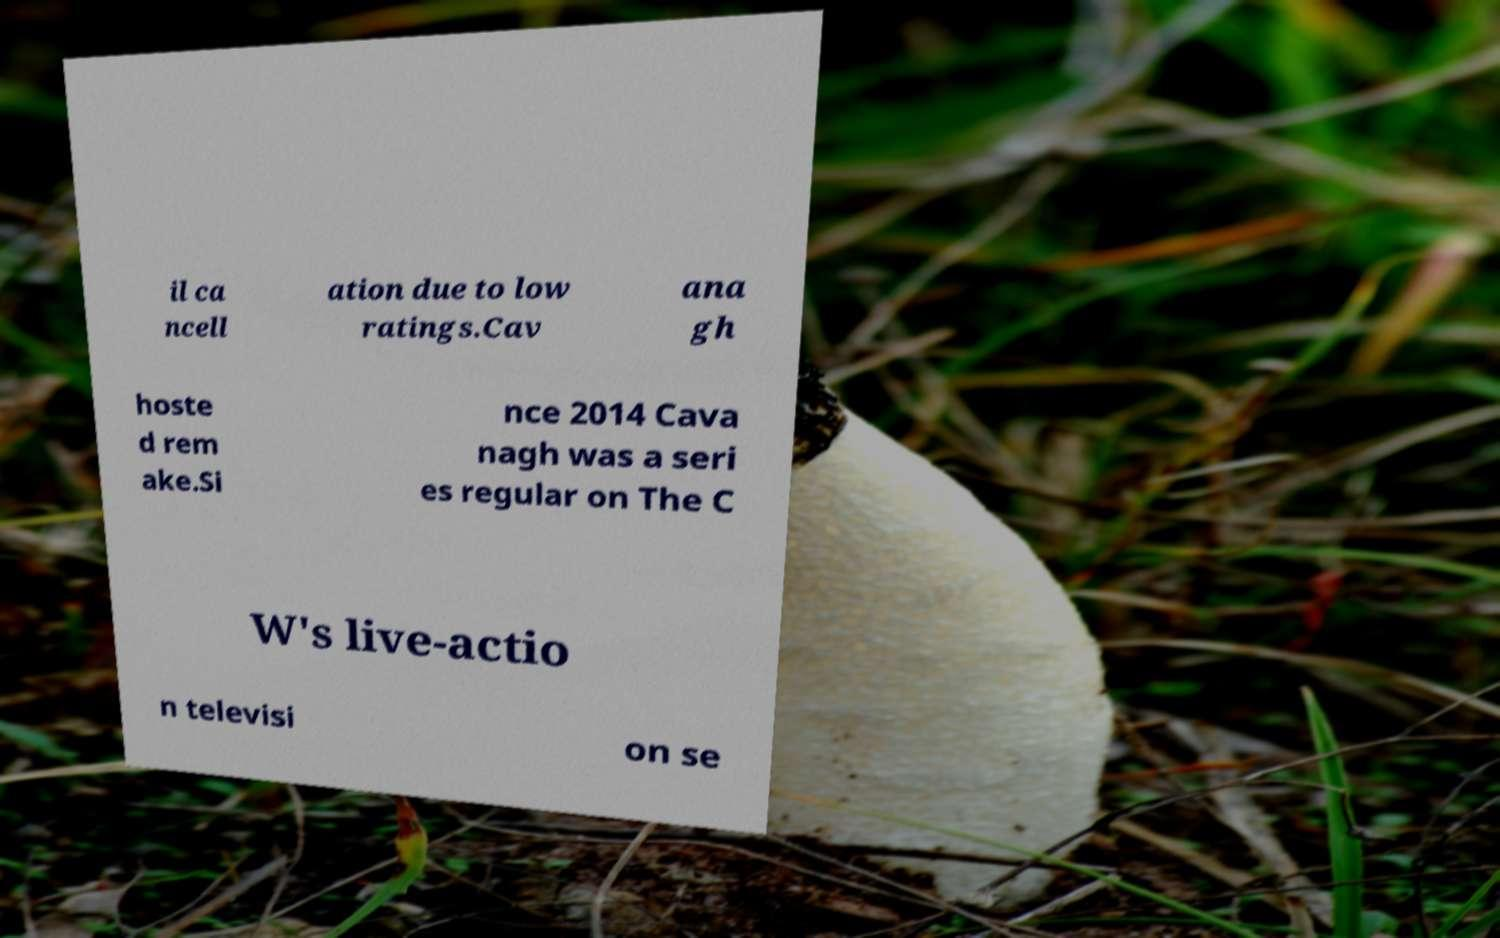Could you extract and type out the text from this image? il ca ncell ation due to low ratings.Cav ana gh hoste d rem ake.Si nce 2014 Cava nagh was a seri es regular on The C W's live-actio n televisi on se 